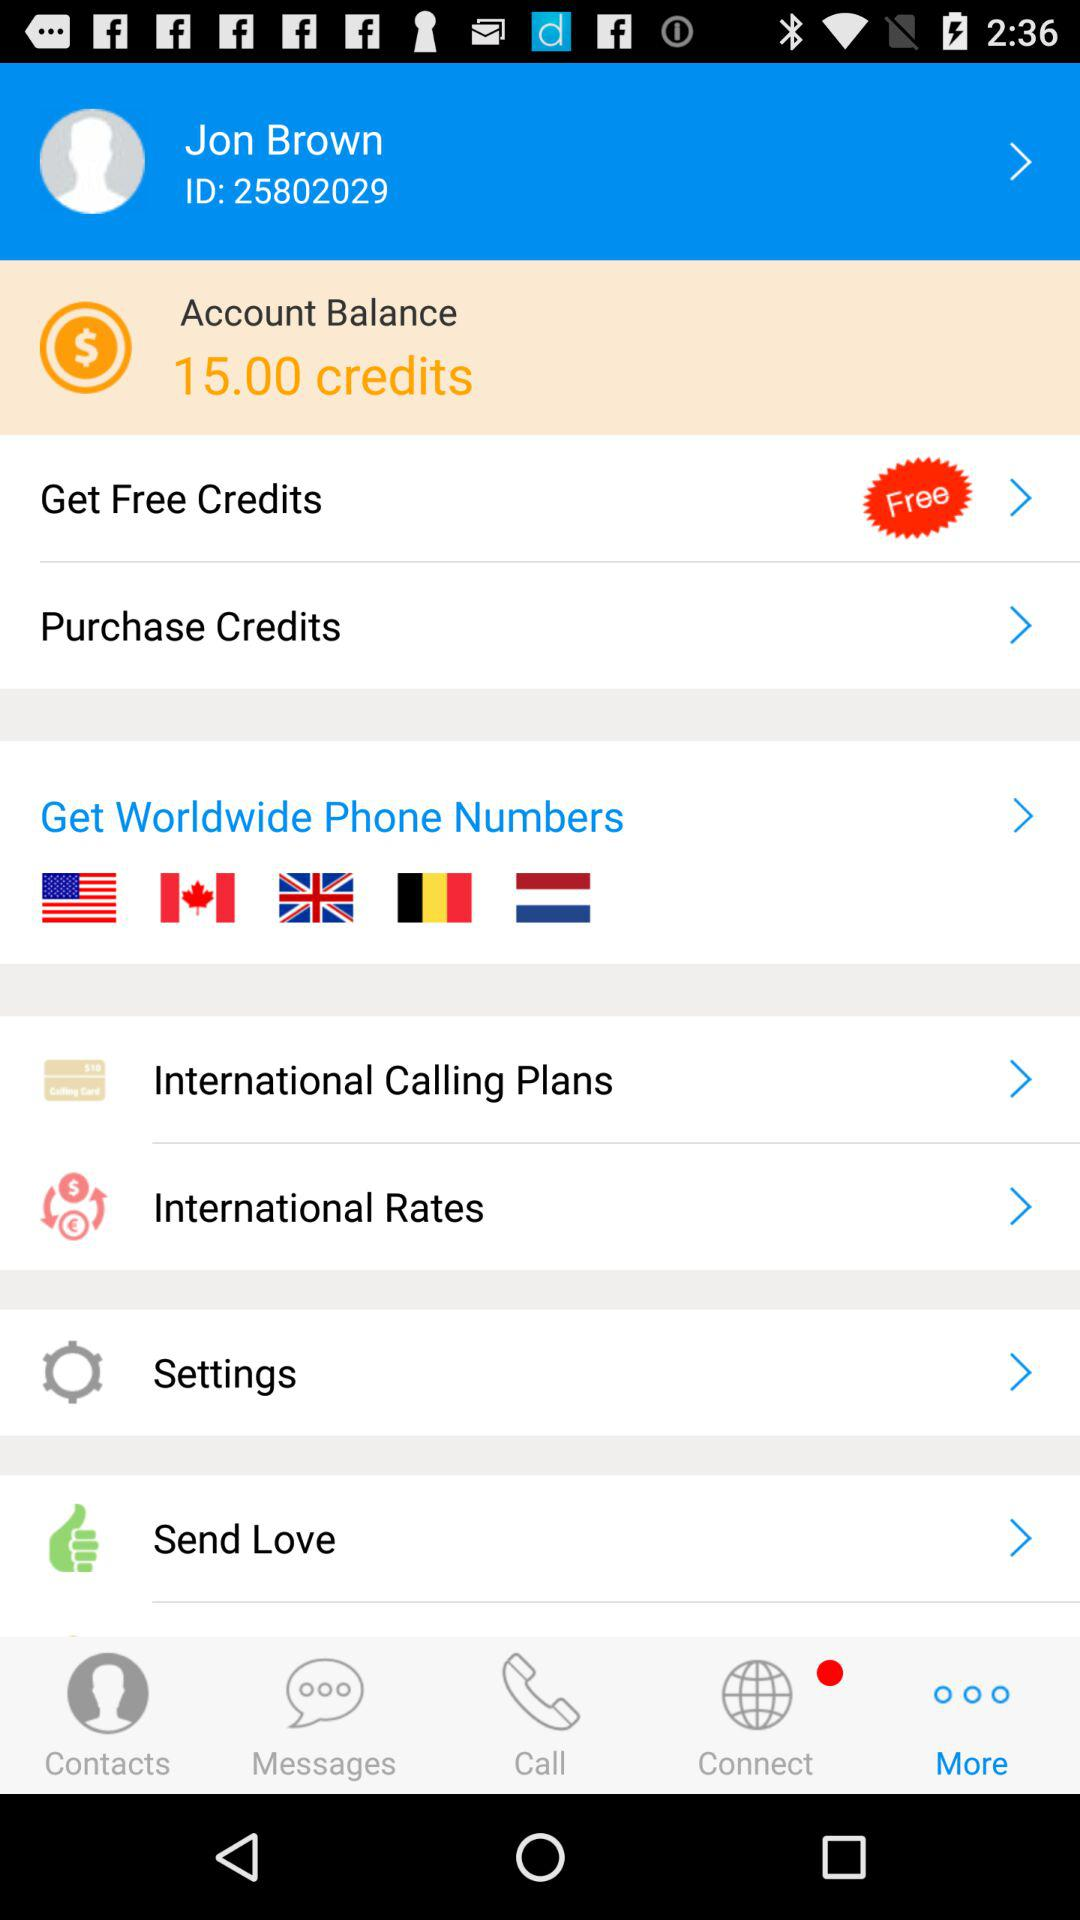What is the balance in the account? The account balance is 15.00 credits. 